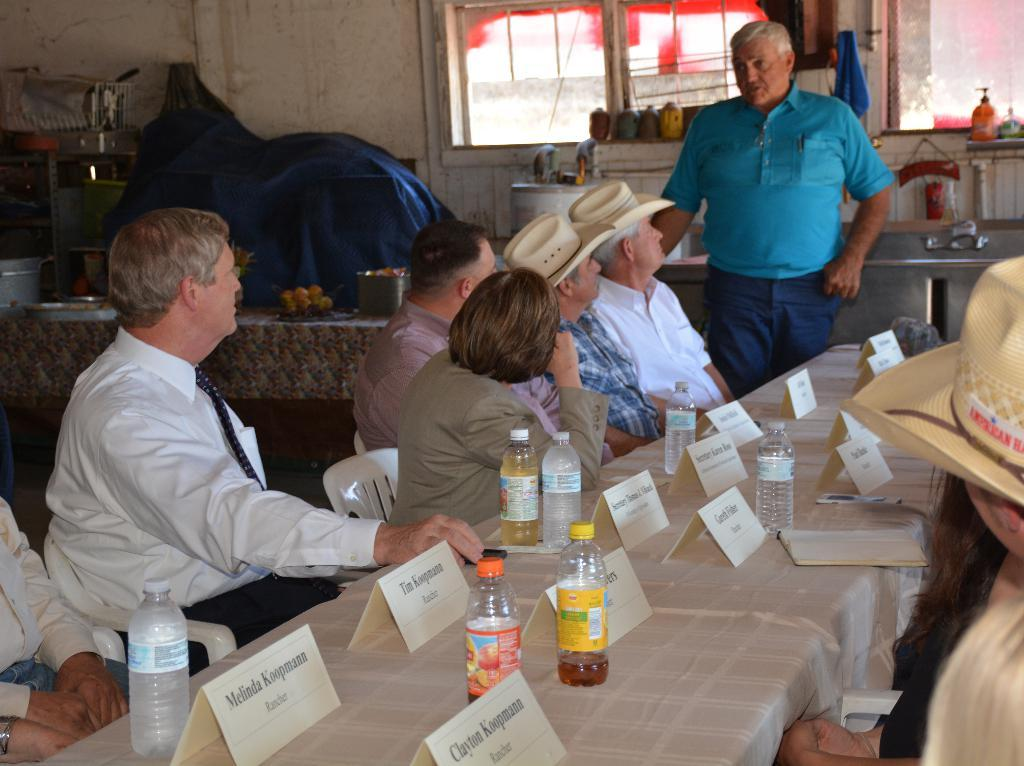What are the people in the image doing? The people in the image are sitting on chairs at a table. What can be seen on the table with the people? There are water bottles and a book on the table. What is visible in the background of the image? There is a wall, a window, and a sink in the background. Are there any other objects visible in the background? Yes, there are fruits on a table in the background. What type of oatmeal is being served in the image? There is no oatmeal present in the image. How does the behavior of the people sitting at the table reflect their relationship with each other? The image does not provide enough information to determine the behavior or relationship between the people sitting at the table. 